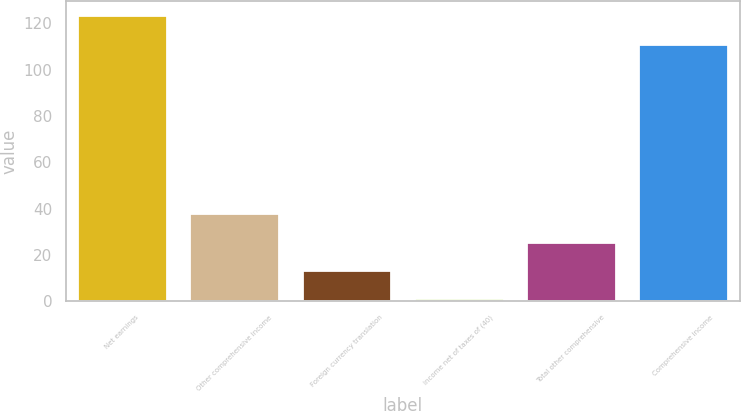Convert chart to OTSL. <chart><loc_0><loc_0><loc_500><loc_500><bar_chart><fcel>Net earnings<fcel>Other comprehensive income<fcel>Foreign currency translation<fcel>income net of taxes of (40)<fcel>Total other comprehensive<fcel>Comprehensive income<nl><fcel>123.6<fcel>37.85<fcel>13.35<fcel>1.1<fcel>25.6<fcel>111<nl></chart> 